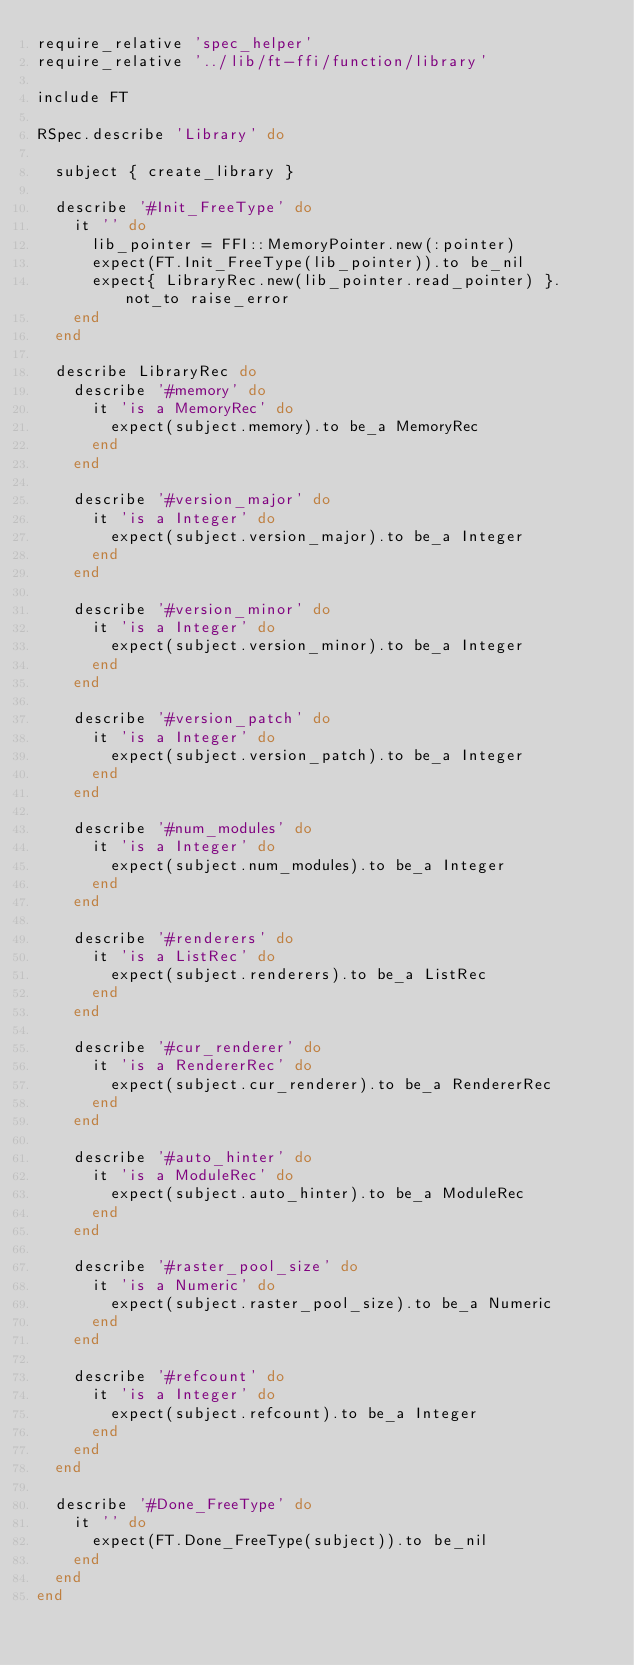Convert code to text. <code><loc_0><loc_0><loc_500><loc_500><_Ruby_>require_relative 'spec_helper'
require_relative '../lib/ft-ffi/function/library'

include FT

RSpec.describe 'Library' do

  subject { create_library }

  describe '#Init_FreeType' do
    it '' do
      lib_pointer = FFI::MemoryPointer.new(:pointer)
      expect(FT.Init_FreeType(lib_pointer)).to be_nil
      expect{ LibraryRec.new(lib_pointer.read_pointer) }.not_to raise_error
    end
  end

  describe LibraryRec do
    describe '#memory' do
      it 'is a MemoryRec' do
        expect(subject.memory).to be_a MemoryRec
      end
    end

    describe '#version_major' do
      it 'is a Integer' do
        expect(subject.version_major).to be_a Integer
      end
    end

    describe '#version_minor' do
      it 'is a Integer' do
        expect(subject.version_minor).to be_a Integer
      end
    end

    describe '#version_patch' do
      it 'is a Integer' do
        expect(subject.version_patch).to be_a Integer
      end
    end

    describe '#num_modules' do
      it 'is a Integer' do
        expect(subject.num_modules).to be_a Integer
      end
    end

    describe '#renderers' do
      it 'is a ListRec' do
        expect(subject.renderers).to be_a ListRec
      end
    end

    describe '#cur_renderer' do
      it 'is a RendererRec' do
        expect(subject.cur_renderer).to be_a RendererRec
      end
    end

    describe '#auto_hinter' do
      it 'is a ModuleRec' do
        expect(subject.auto_hinter).to be_a ModuleRec
      end
    end

    describe '#raster_pool_size' do
      it 'is a Numeric' do
        expect(subject.raster_pool_size).to be_a Numeric
      end
    end

    describe '#refcount' do
      it 'is a Integer' do
        expect(subject.refcount).to be_a Integer
      end
    end
  end

  describe '#Done_FreeType' do
    it '' do
      expect(FT.Done_FreeType(subject)).to be_nil
    end
  end
end</code> 